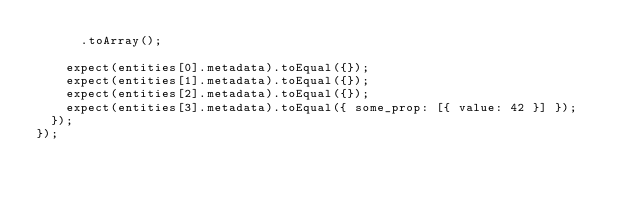<code> <loc_0><loc_0><loc_500><loc_500><_JavaScript_>      .toArray();

    expect(entities[0].metadata).toEqual({});
    expect(entities[1].metadata).toEqual({});
    expect(entities[2].metadata).toEqual({});
    expect(entities[3].metadata).toEqual({ some_prop: [{ value: 42 }] });
  });
});
</code> 